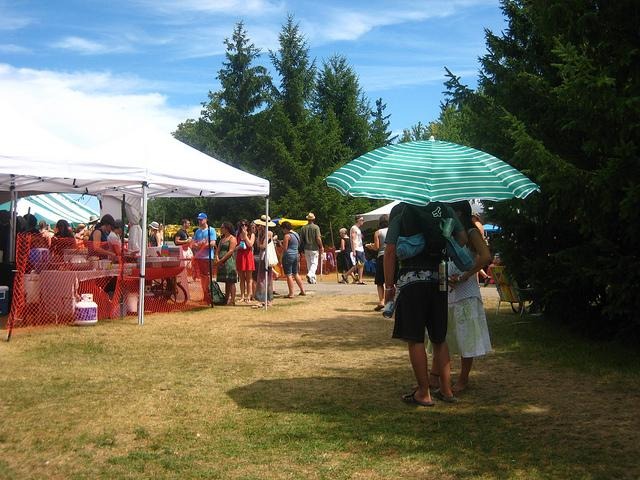What is the green umbrella being used to block? sun 